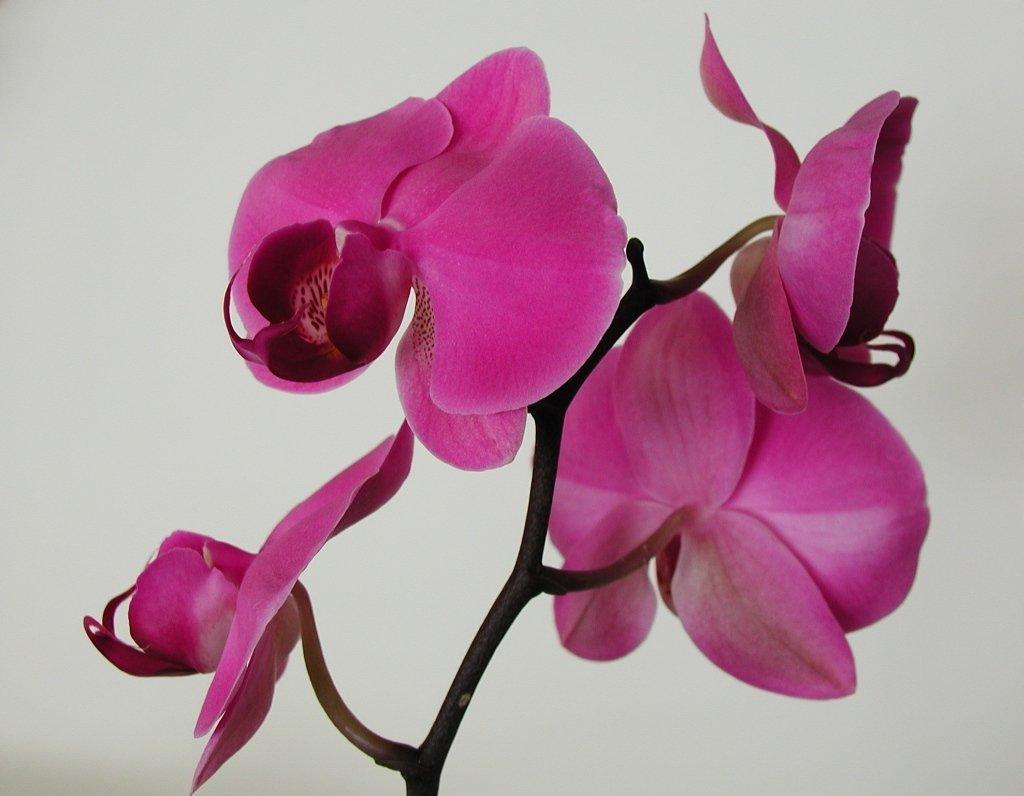What color are the flowers in the image? The flowers in the image are pink. How are the flowers arranged in the image? The flowers are on a stem. What color is the background of the image? The background of the image is white. How many goats can be seen grazing in the mine in the image? There are no goats or mines present in the image; it features pink flowers on a stem with a white background. 